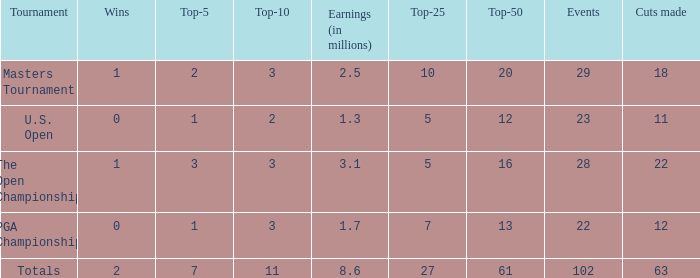Can you give me this table as a dict? {'header': ['Tournament', 'Wins', 'Top-5', 'Top-10', 'Earnings (in millions)', 'Top-25', 'Top-50', 'Events', 'Cuts made'], 'rows': [['Masters Tournament', '1', '2', '3', '2.5', '10', '20', '29', '18'], ['U.S. Open', '0', '1', '2', '1.3', '5', '12', '23', '11'], ['The Open Championship', '1', '3', '3', '3.1', '5', '16', '28', '22'], ['PGA Championship', '0', '1', '3', '1.7', '7', '13', '22', '12'], ['Totals', '2', '7', '11', '8.6', '27', '61', '102', '63']]} How many vuts made for a player with 2 wins and under 7 top 5s? None. 